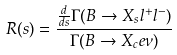<formula> <loc_0><loc_0><loc_500><loc_500>R ( s ) = \frac { \frac { d } { d s } \Gamma ( B \to X _ { s } l ^ { + } l ^ { - } ) } { \Gamma ( B \to X _ { c } e \nu ) }</formula> 